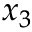<formula> <loc_0><loc_0><loc_500><loc_500>x _ { 3 }</formula> 